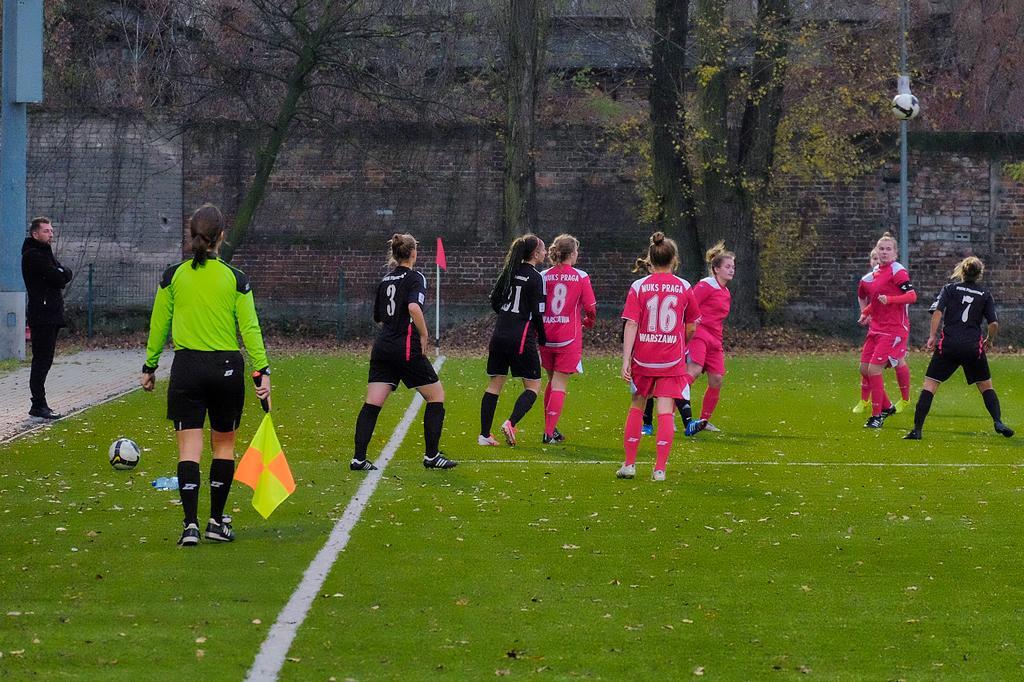Please provide a concise description of this image. In this picture we can see group of people, few people playing game in the ground, on the left and right hand side of the image we can see balls, in the background we can find few trees and poles. 